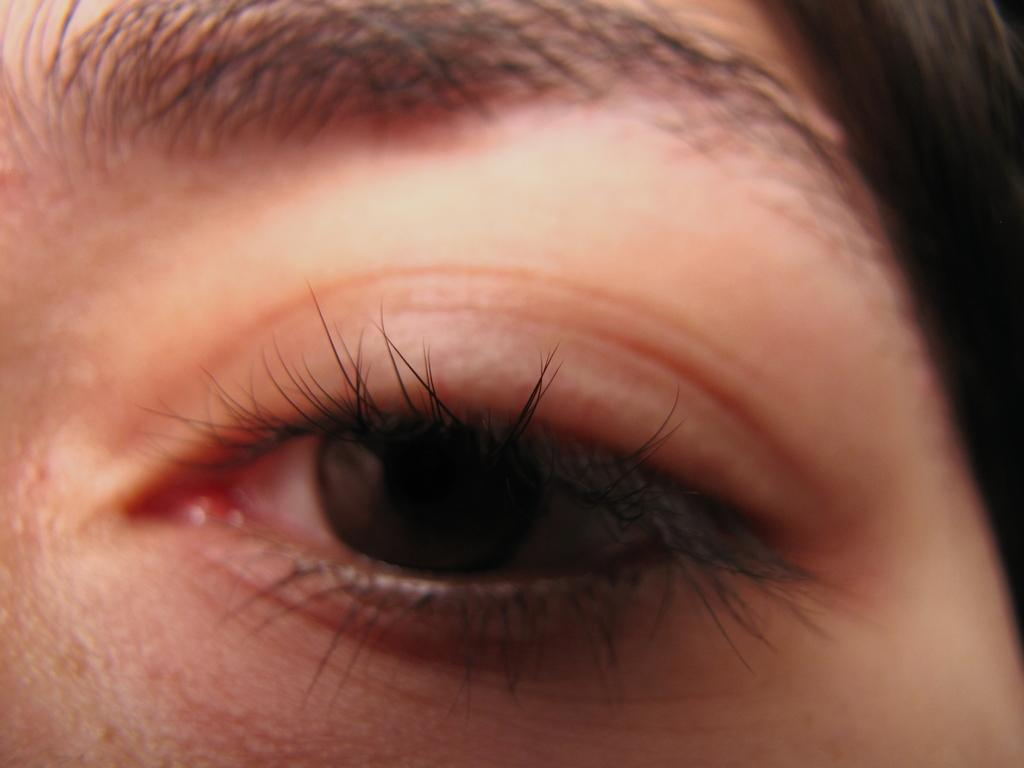What is the main subject of the image? The main subject of the image is the eye of a person. Can you describe the eye in the image? The eye appears to be a close-up view of a person's eye. What type of cable is connected to the eye in the image? There is no cable connected to the eye in the image; it is a close-up view of a person's eye. Is there a gun visible in the image? No, there is no gun present in the image; it is a close-up view of a person's eye. 